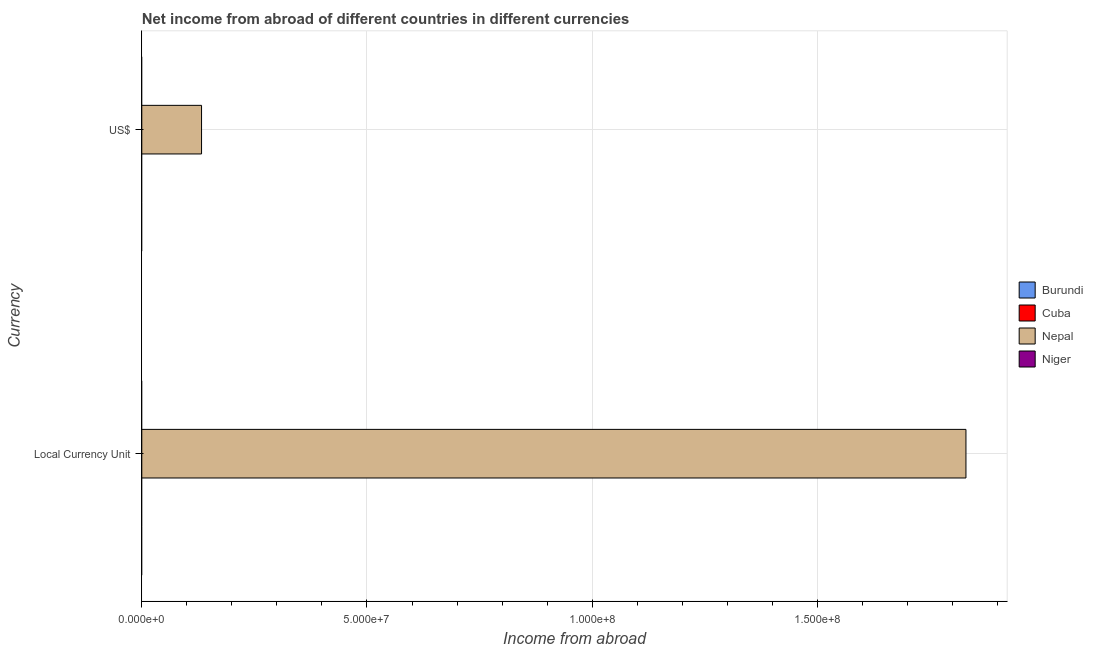Are the number of bars per tick equal to the number of legend labels?
Give a very brief answer. No. Are the number of bars on each tick of the Y-axis equal?
Offer a terse response. Yes. How many bars are there on the 1st tick from the bottom?
Your response must be concise. 1. What is the label of the 2nd group of bars from the top?
Provide a succinct answer. Local Currency Unit. What is the income from abroad in constant 2005 us$ in Burundi?
Your answer should be very brief. 0. Across all countries, what is the maximum income from abroad in us$?
Your answer should be very brief. 1.33e+07. In which country was the income from abroad in constant 2005 us$ maximum?
Make the answer very short. Nepal. What is the total income from abroad in us$ in the graph?
Offer a very short reply. 1.33e+07. What is the difference between the income from abroad in constant 2005 us$ in Niger and the income from abroad in us$ in Cuba?
Ensure brevity in your answer.  0. What is the average income from abroad in us$ per country?
Make the answer very short. 3.32e+06. What is the difference between the income from abroad in constant 2005 us$ and income from abroad in us$ in Nepal?
Make the answer very short. 1.70e+08. In how many countries, is the income from abroad in constant 2005 us$ greater than 130000000 units?
Provide a succinct answer. 1. In how many countries, is the income from abroad in us$ greater than the average income from abroad in us$ taken over all countries?
Offer a very short reply. 1. Are all the bars in the graph horizontal?
Keep it short and to the point. Yes. Are the values on the major ticks of X-axis written in scientific E-notation?
Ensure brevity in your answer.  Yes. Does the graph contain grids?
Give a very brief answer. Yes. Where does the legend appear in the graph?
Give a very brief answer. Center right. How many legend labels are there?
Keep it short and to the point. 4. What is the title of the graph?
Offer a terse response. Net income from abroad of different countries in different currencies. Does "Sweden" appear as one of the legend labels in the graph?
Ensure brevity in your answer.  No. What is the label or title of the X-axis?
Your answer should be very brief. Income from abroad. What is the label or title of the Y-axis?
Give a very brief answer. Currency. What is the Income from abroad in Nepal in Local Currency Unit?
Your answer should be compact. 1.83e+08. What is the Income from abroad of Niger in Local Currency Unit?
Make the answer very short. 0. What is the Income from abroad in Burundi in US$?
Keep it short and to the point. 0. What is the Income from abroad of Nepal in US$?
Ensure brevity in your answer.  1.33e+07. Across all Currency, what is the maximum Income from abroad in Nepal?
Ensure brevity in your answer.  1.83e+08. Across all Currency, what is the minimum Income from abroad in Nepal?
Your answer should be very brief. 1.33e+07. What is the total Income from abroad in Burundi in the graph?
Offer a terse response. 0. What is the total Income from abroad of Nepal in the graph?
Ensure brevity in your answer.  1.96e+08. What is the difference between the Income from abroad of Nepal in Local Currency Unit and that in US$?
Provide a short and direct response. 1.70e+08. What is the average Income from abroad of Burundi per Currency?
Ensure brevity in your answer.  0. What is the average Income from abroad of Cuba per Currency?
Keep it short and to the point. 0. What is the average Income from abroad in Nepal per Currency?
Provide a succinct answer. 9.81e+07. What is the ratio of the Income from abroad in Nepal in Local Currency Unit to that in US$?
Offer a terse response. 13.8. What is the difference between the highest and the second highest Income from abroad in Nepal?
Your answer should be compact. 1.70e+08. What is the difference between the highest and the lowest Income from abroad in Nepal?
Provide a short and direct response. 1.70e+08. 